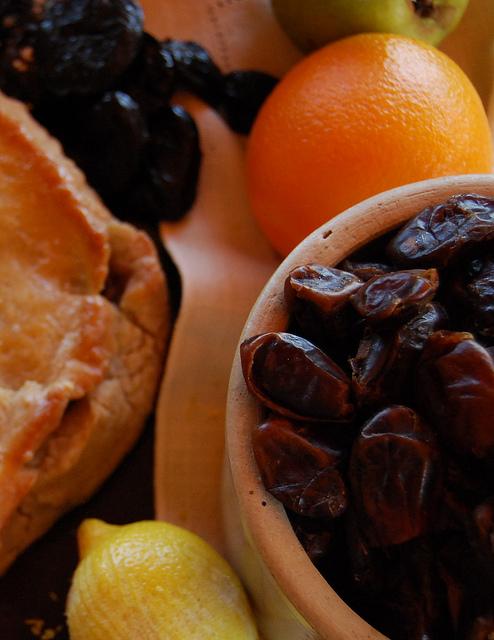What drink can you make from this object?
Concise answer only. Juice. Was this food deep fried?
Concise answer only. No. How many intact pieces of fruit are in this scene?
Quick response, please. 2. Are raisins in this photo?
Answer briefly. Yes. Is the orange clean?
Answer briefly. Yes. Is the bowl made of wood?
Keep it brief. Yes. Are these fruits grown on trees?
Write a very short answer. Yes. What fruits are these?
Give a very brief answer. Dates. Are the fruits at the peak of their flavor?
Write a very short answer. Yes. What is the fruit in the back?
Short answer required. Orange. Which fruit can be sliced in half and juiced?
Concise answer only. Orange. 